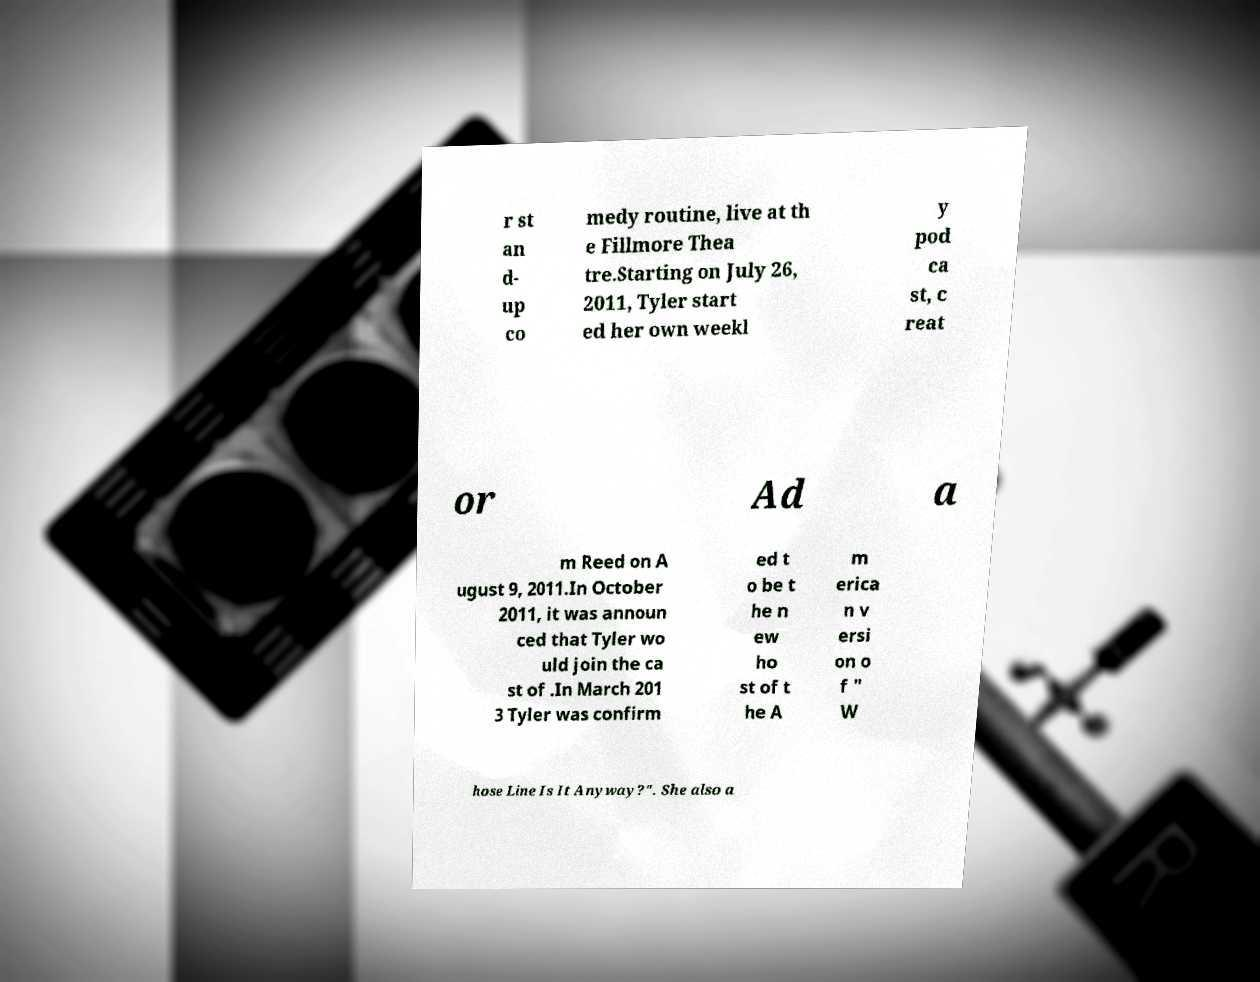What messages or text are displayed in this image? I need them in a readable, typed format. r st an d- up co medy routine, live at th e Fillmore Thea tre.Starting on July 26, 2011, Tyler start ed her own weekl y pod ca st, c reat or Ad a m Reed on A ugust 9, 2011.In October 2011, it was announ ced that Tyler wo uld join the ca st of .In March 201 3 Tyler was confirm ed t o be t he n ew ho st of t he A m erica n v ersi on o f " W hose Line Is It Anyway?". She also a 